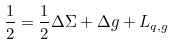<formula> <loc_0><loc_0><loc_500><loc_500>\frac { 1 } { 2 } = \frac { 1 } { 2 } \Delta \Sigma + \Delta g + L _ { q , g }</formula> 